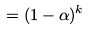<formula> <loc_0><loc_0><loc_500><loc_500>= ( 1 - \alpha ) ^ { k }</formula> 